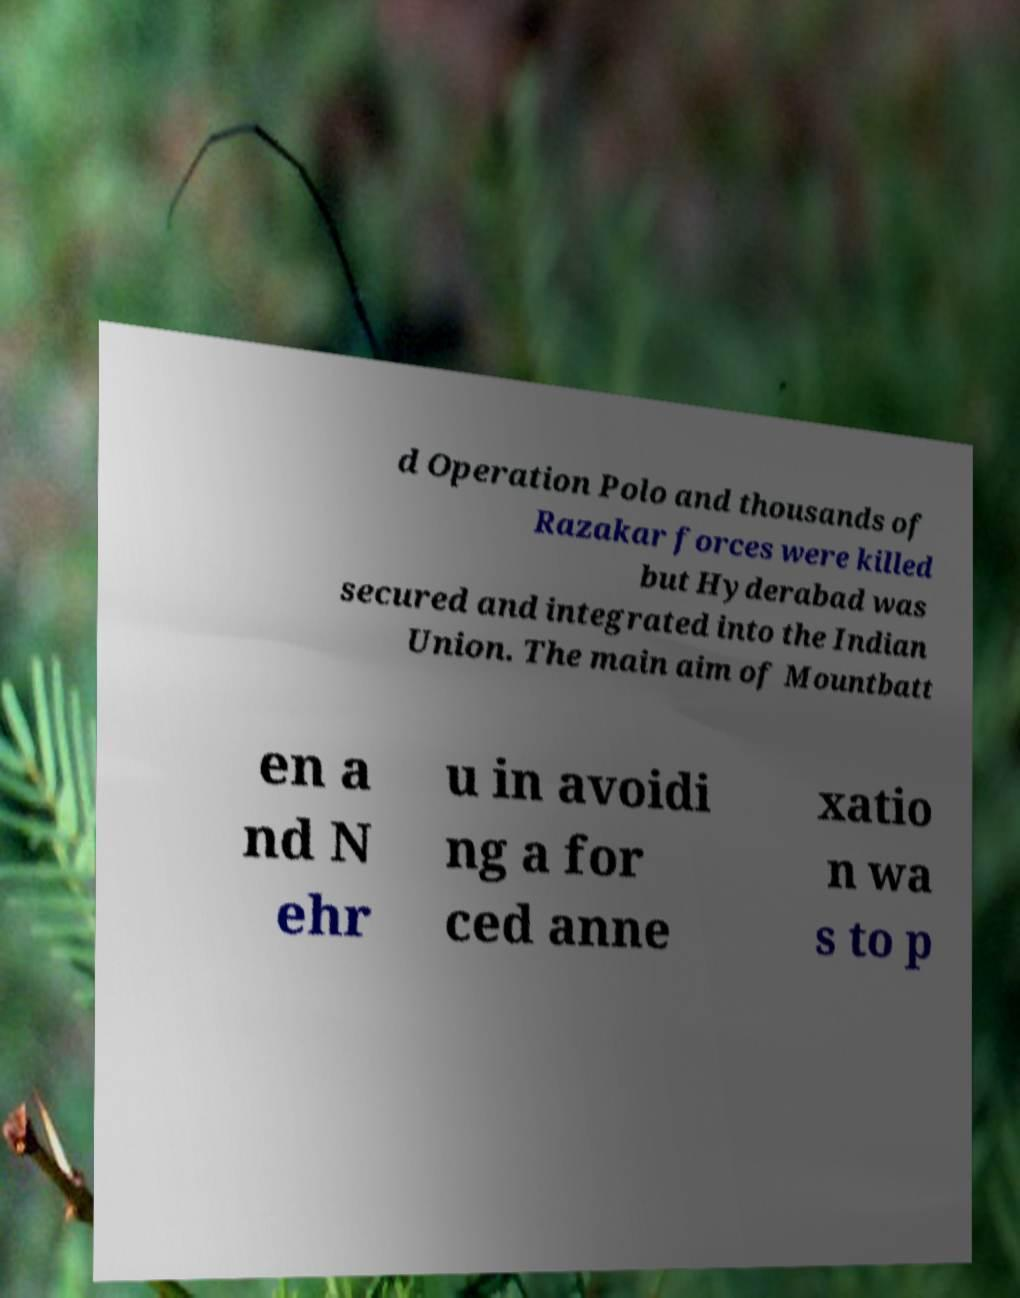Could you extract and type out the text from this image? d Operation Polo and thousands of Razakar forces were killed but Hyderabad was secured and integrated into the Indian Union. The main aim of Mountbatt en a nd N ehr u in avoidi ng a for ced anne xatio n wa s to p 